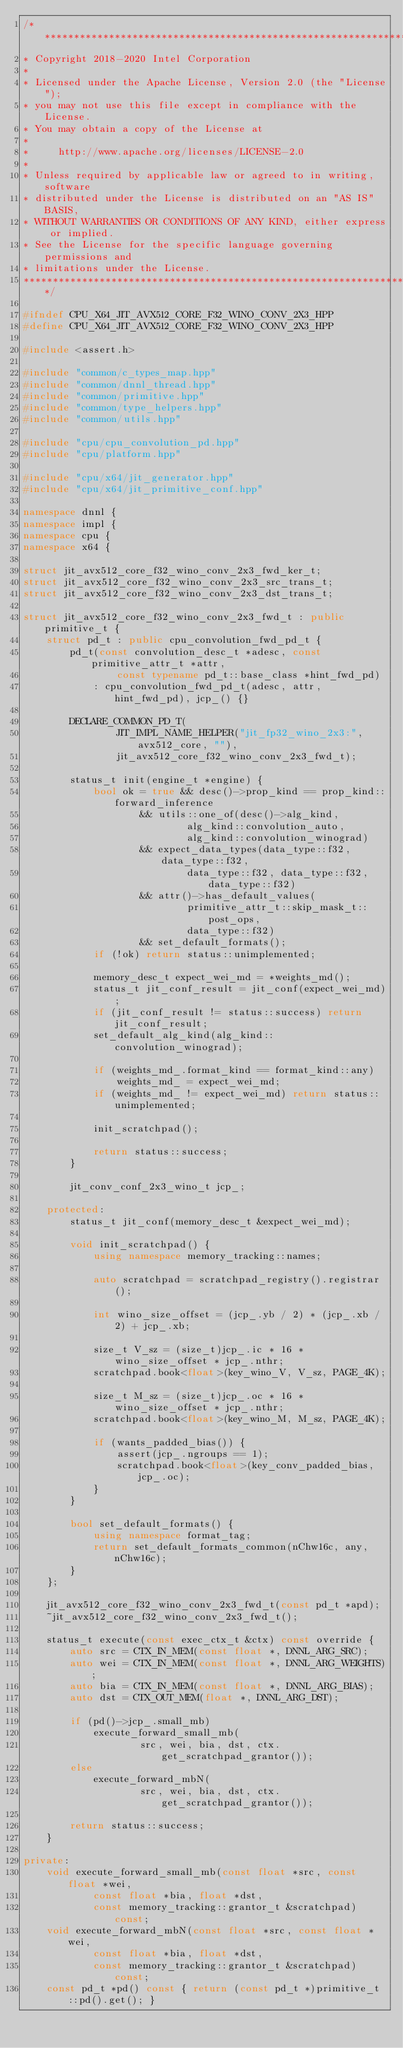Convert code to text. <code><loc_0><loc_0><loc_500><loc_500><_C++_>/*******************************************************************************
* Copyright 2018-2020 Intel Corporation
*
* Licensed under the Apache License, Version 2.0 (the "License");
* you may not use this file except in compliance with the License.
* You may obtain a copy of the License at
*
*     http://www.apache.org/licenses/LICENSE-2.0
*
* Unless required by applicable law or agreed to in writing, software
* distributed under the License is distributed on an "AS IS" BASIS,
* WITHOUT WARRANTIES OR CONDITIONS OF ANY KIND, either express or implied.
* See the License for the specific language governing permissions and
* limitations under the License.
*******************************************************************************/

#ifndef CPU_X64_JIT_AVX512_CORE_F32_WINO_CONV_2X3_HPP
#define CPU_X64_JIT_AVX512_CORE_F32_WINO_CONV_2X3_HPP

#include <assert.h>

#include "common/c_types_map.hpp"
#include "common/dnnl_thread.hpp"
#include "common/primitive.hpp"
#include "common/type_helpers.hpp"
#include "common/utils.hpp"

#include "cpu/cpu_convolution_pd.hpp"
#include "cpu/platform.hpp"

#include "cpu/x64/jit_generator.hpp"
#include "cpu/x64/jit_primitive_conf.hpp"

namespace dnnl {
namespace impl {
namespace cpu {
namespace x64 {

struct jit_avx512_core_f32_wino_conv_2x3_fwd_ker_t;
struct jit_avx512_core_f32_wino_conv_2x3_src_trans_t;
struct jit_avx512_core_f32_wino_conv_2x3_dst_trans_t;

struct jit_avx512_core_f32_wino_conv_2x3_fwd_t : public primitive_t {
    struct pd_t : public cpu_convolution_fwd_pd_t {
        pd_t(const convolution_desc_t *adesc, const primitive_attr_t *attr,
                const typename pd_t::base_class *hint_fwd_pd)
            : cpu_convolution_fwd_pd_t(adesc, attr, hint_fwd_pd), jcp_() {}

        DECLARE_COMMON_PD_T(
                JIT_IMPL_NAME_HELPER("jit_fp32_wino_2x3:", avx512_core, ""),
                jit_avx512_core_f32_wino_conv_2x3_fwd_t);

        status_t init(engine_t *engine) {
            bool ok = true && desc()->prop_kind == prop_kind::forward_inference
                    && utils::one_of(desc()->alg_kind,
                            alg_kind::convolution_auto,
                            alg_kind::convolution_winograd)
                    && expect_data_types(data_type::f32, data_type::f32,
                            data_type::f32, data_type::f32, data_type::f32)
                    && attr()->has_default_values(
                            primitive_attr_t::skip_mask_t::post_ops,
                            data_type::f32)
                    && set_default_formats();
            if (!ok) return status::unimplemented;

            memory_desc_t expect_wei_md = *weights_md();
            status_t jit_conf_result = jit_conf(expect_wei_md);
            if (jit_conf_result != status::success) return jit_conf_result;
            set_default_alg_kind(alg_kind::convolution_winograd);

            if (weights_md_.format_kind == format_kind::any)
                weights_md_ = expect_wei_md;
            if (weights_md_ != expect_wei_md) return status::unimplemented;

            init_scratchpad();

            return status::success;
        }

        jit_conv_conf_2x3_wino_t jcp_;

    protected:
        status_t jit_conf(memory_desc_t &expect_wei_md);

        void init_scratchpad() {
            using namespace memory_tracking::names;

            auto scratchpad = scratchpad_registry().registrar();

            int wino_size_offset = (jcp_.yb / 2) * (jcp_.xb / 2) + jcp_.xb;

            size_t V_sz = (size_t)jcp_.ic * 16 * wino_size_offset * jcp_.nthr;
            scratchpad.book<float>(key_wino_V, V_sz, PAGE_4K);

            size_t M_sz = (size_t)jcp_.oc * 16 * wino_size_offset * jcp_.nthr;
            scratchpad.book<float>(key_wino_M, M_sz, PAGE_4K);

            if (wants_padded_bias()) {
                assert(jcp_.ngroups == 1);
                scratchpad.book<float>(key_conv_padded_bias, jcp_.oc);
            }
        }

        bool set_default_formats() {
            using namespace format_tag;
            return set_default_formats_common(nChw16c, any, nChw16c);
        }
    };

    jit_avx512_core_f32_wino_conv_2x3_fwd_t(const pd_t *apd);
    ~jit_avx512_core_f32_wino_conv_2x3_fwd_t();

    status_t execute(const exec_ctx_t &ctx) const override {
        auto src = CTX_IN_MEM(const float *, DNNL_ARG_SRC);
        auto wei = CTX_IN_MEM(const float *, DNNL_ARG_WEIGHTS);
        auto bia = CTX_IN_MEM(const float *, DNNL_ARG_BIAS);
        auto dst = CTX_OUT_MEM(float *, DNNL_ARG_DST);

        if (pd()->jcp_.small_mb)
            execute_forward_small_mb(
                    src, wei, bia, dst, ctx.get_scratchpad_grantor());
        else
            execute_forward_mbN(
                    src, wei, bia, dst, ctx.get_scratchpad_grantor());

        return status::success;
    }

private:
    void execute_forward_small_mb(const float *src, const float *wei,
            const float *bia, float *dst,
            const memory_tracking::grantor_t &scratchpad) const;
    void execute_forward_mbN(const float *src, const float *wei,
            const float *bia, float *dst,
            const memory_tracking::grantor_t &scratchpad) const;
    const pd_t *pd() const { return (const pd_t *)primitive_t::pd().get(); }
</code> 